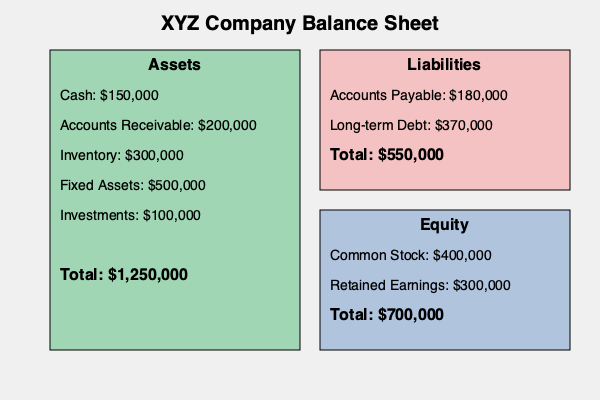Based on the color-coded balance sheet visualization, calculate the debt-to-equity ratio for XYZ Company. Round your answer to two decimal places. To calculate the debt-to-equity ratio, we need to follow these steps:

1. Identify the total liabilities (debt):
   - The red section represents liabilities
   - Total liabilities = $550,000

2. Identify the total equity:
   - The blue section represents equity
   - Total equity = $700,000

3. Apply the debt-to-equity ratio formula:
   Debt-to-Equity Ratio = Total Liabilities / Total Equity
   
4. Perform the calculation:
   Debt-to-Equity Ratio = $550,000 / $700,000 = 0.7857142857

5. Round the result to two decimal places:
   0.7857142857 ≈ 0.79

The debt-to-equity ratio of 0.79 indicates that for every dollar of equity, the company has $0.79 in debt. This suggests that XYZ Company is financed more by equity than by debt, which generally indicates a lower financial risk.
Answer: 0.79 